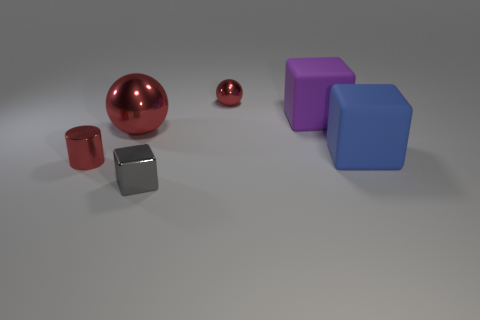Subtract all rubber blocks. How many blocks are left? 1 Add 1 big purple shiny objects. How many objects exist? 7 Subtract all cylinders. How many objects are left? 5 Add 6 gray metal things. How many gray metal things exist? 7 Subtract 2 red spheres. How many objects are left? 4 Subtract all large gray cylinders. Subtract all gray blocks. How many objects are left? 5 Add 4 big red objects. How many big red objects are left? 5 